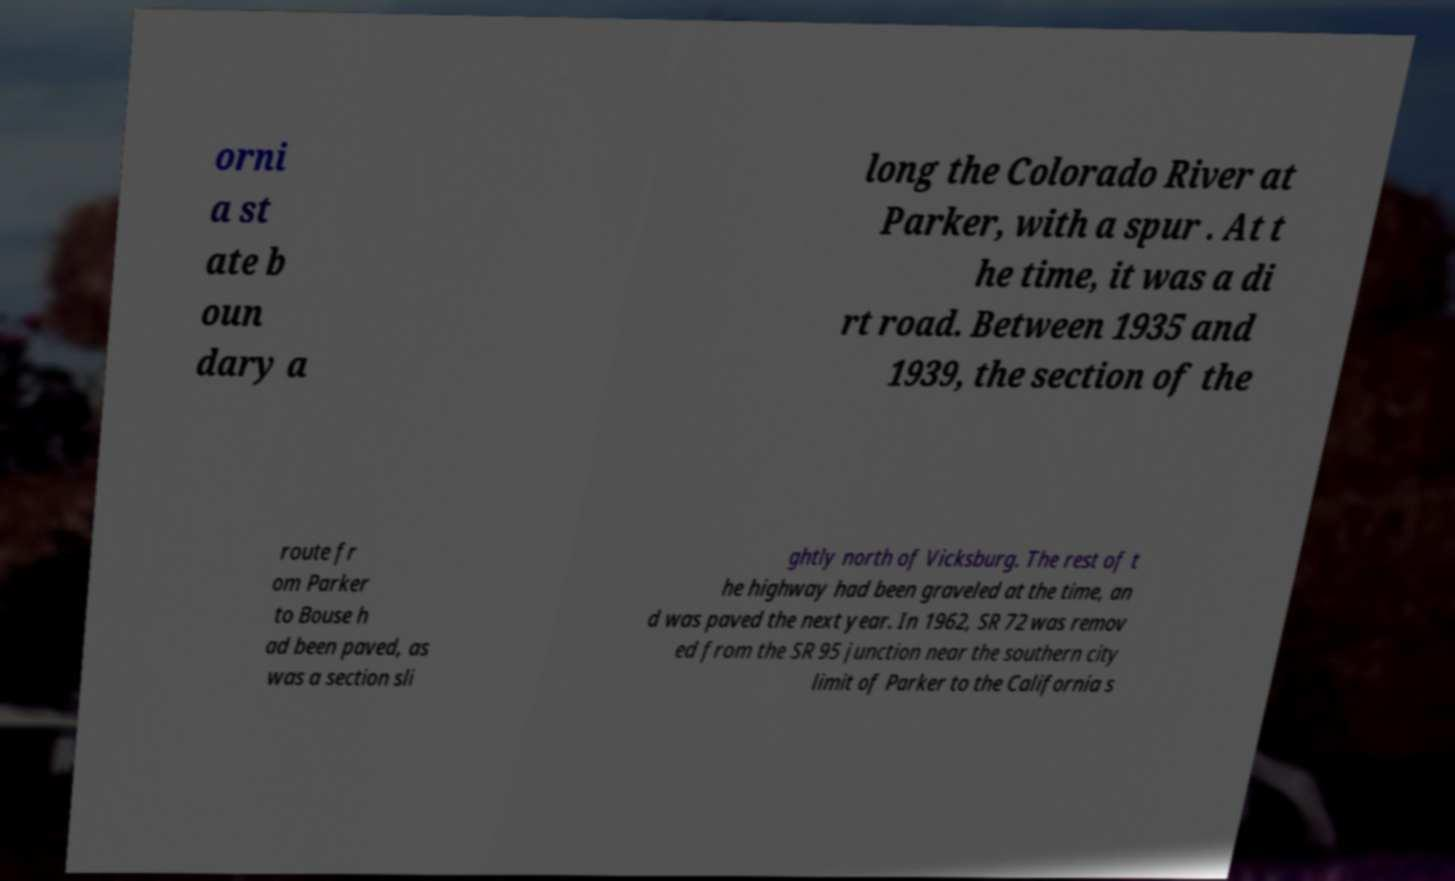There's text embedded in this image that I need extracted. Can you transcribe it verbatim? orni a st ate b oun dary a long the Colorado River at Parker, with a spur . At t he time, it was a di rt road. Between 1935 and 1939, the section of the route fr om Parker to Bouse h ad been paved, as was a section sli ghtly north of Vicksburg. The rest of t he highway had been graveled at the time, an d was paved the next year. In 1962, SR 72 was remov ed from the SR 95 junction near the southern city limit of Parker to the California s 